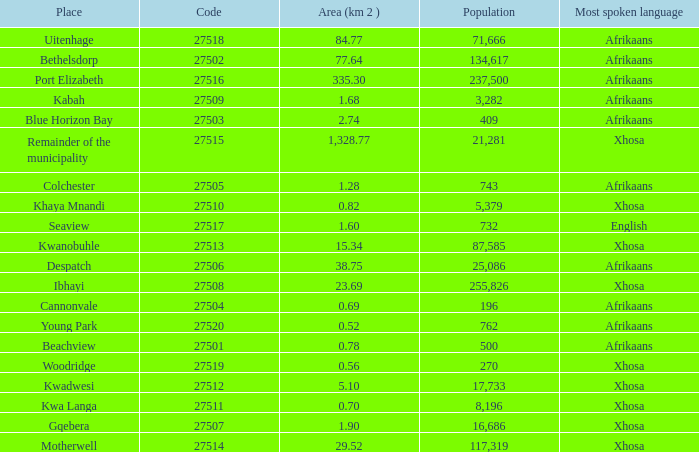What is the total code number for places with a population greater than 87,585? 4.0. 